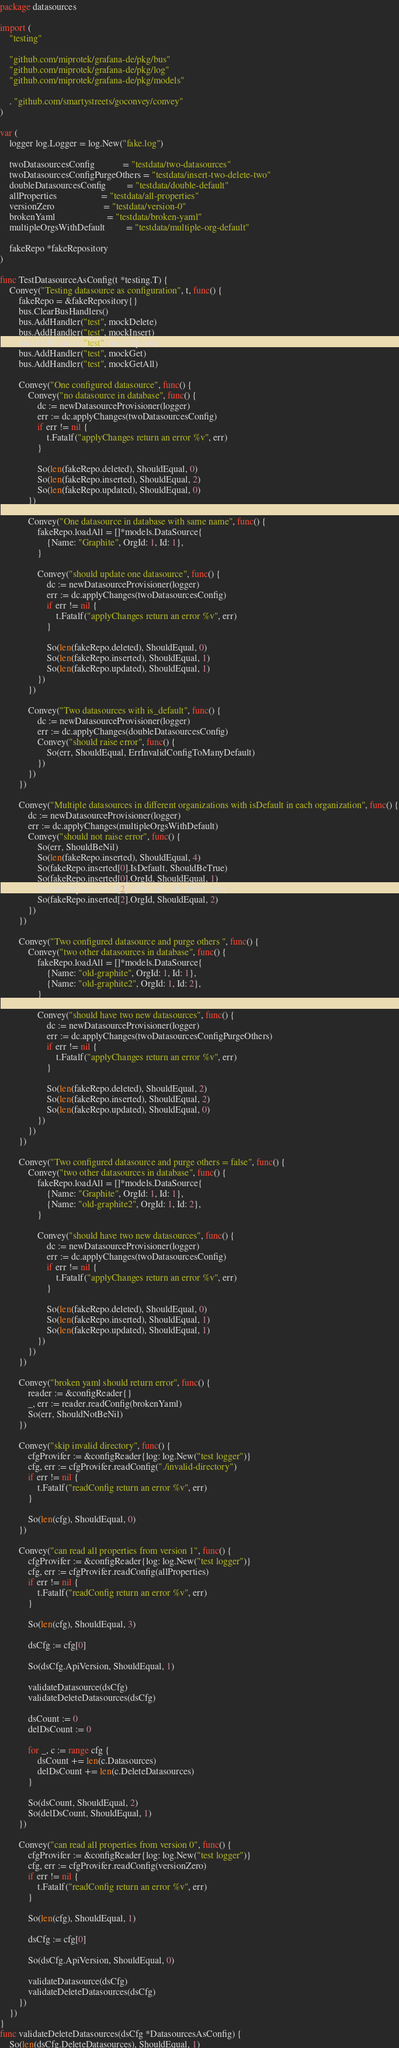<code> <loc_0><loc_0><loc_500><loc_500><_Go_>package datasources

import (
	"testing"

	"github.com/miprotek/grafana-de/pkg/bus"
	"github.com/miprotek/grafana-de/pkg/log"
	"github.com/miprotek/grafana-de/pkg/models"

	. "github.com/smartystreets/goconvey/convey"
)

var (
	logger log.Logger = log.New("fake.log")

	twoDatasourcesConfig            = "testdata/two-datasources"
	twoDatasourcesConfigPurgeOthers = "testdata/insert-two-delete-two"
	doubleDatasourcesConfig         = "testdata/double-default"
	allProperties                   = "testdata/all-properties"
	versionZero                     = "testdata/version-0"
	brokenYaml                      = "testdata/broken-yaml"
	multipleOrgsWithDefault         = "testdata/multiple-org-default"

	fakeRepo *fakeRepository
)

func TestDatasourceAsConfig(t *testing.T) {
	Convey("Testing datasource as configuration", t, func() {
		fakeRepo = &fakeRepository{}
		bus.ClearBusHandlers()
		bus.AddHandler("test", mockDelete)
		bus.AddHandler("test", mockInsert)
		bus.AddHandler("test", mockUpdate)
		bus.AddHandler("test", mockGet)
		bus.AddHandler("test", mockGetAll)

		Convey("One configured datasource", func() {
			Convey("no datasource in database", func() {
				dc := newDatasourceProvisioner(logger)
				err := dc.applyChanges(twoDatasourcesConfig)
				if err != nil {
					t.Fatalf("applyChanges return an error %v", err)
				}

				So(len(fakeRepo.deleted), ShouldEqual, 0)
				So(len(fakeRepo.inserted), ShouldEqual, 2)
				So(len(fakeRepo.updated), ShouldEqual, 0)
			})

			Convey("One datasource in database with same name", func() {
				fakeRepo.loadAll = []*models.DataSource{
					{Name: "Graphite", OrgId: 1, Id: 1},
				}

				Convey("should update one datasource", func() {
					dc := newDatasourceProvisioner(logger)
					err := dc.applyChanges(twoDatasourcesConfig)
					if err != nil {
						t.Fatalf("applyChanges return an error %v", err)
					}

					So(len(fakeRepo.deleted), ShouldEqual, 0)
					So(len(fakeRepo.inserted), ShouldEqual, 1)
					So(len(fakeRepo.updated), ShouldEqual, 1)
				})
			})

			Convey("Two datasources with is_default", func() {
				dc := newDatasourceProvisioner(logger)
				err := dc.applyChanges(doubleDatasourcesConfig)
				Convey("should raise error", func() {
					So(err, ShouldEqual, ErrInvalidConfigToManyDefault)
				})
			})
		})

		Convey("Multiple datasources in different organizations with isDefault in each organization", func() {
			dc := newDatasourceProvisioner(logger)
			err := dc.applyChanges(multipleOrgsWithDefault)
			Convey("should not raise error", func() {
				So(err, ShouldBeNil)
				So(len(fakeRepo.inserted), ShouldEqual, 4)
				So(fakeRepo.inserted[0].IsDefault, ShouldBeTrue)
				So(fakeRepo.inserted[0].OrgId, ShouldEqual, 1)
				So(fakeRepo.inserted[2].IsDefault, ShouldBeTrue)
				So(fakeRepo.inserted[2].OrgId, ShouldEqual, 2)
			})
		})

		Convey("Two configured datasource and purge others ", func() {
			Convey("two other datasources in database", func() {
				fakeRepo.loadAll = []*models.DataSource{
					{Name: "old-graphite", OrgId: 1, Id: 1},
					{Name: "old-graphite2", OrgId: 1, Id: 2},
				}

				Convey("should have two new datasources", func() {
					dc := newDatasourceProvisioner(logger)
					err := dc.applyChanges(twoDatasourcesConfigPurgeOthers)
					if err != nil {
						t.Fatalf("applyChanges return an error %v", err)
					}

					So(len(fakeRepo.deleted), ShouldEqual, 2)
					So(len(fakeRepo.inserted), ShouldEqual, 2)
					So(len(fakeRepo.updated), ShouldEqual, 0)
				})
			})
		})

		Convey("Two configured datasource and purge others = false", func() {
			Convey("two other datasources in database", func() {
				fakeRepo.loadAll = []*models.DataSource{
					{Name: "Graphite", OrgId: 1, Id: 1},
					{Name: "old-graphite2", OrgId: 1, Id: 2},
				}

				Convey("should have two new datasources", func() {
					dc := newDatasourceProvisioner(logger)
					err := dc.applyChanges(twoDatasourcesConfig)
					if err != nil {
						t.Fatalf("applyChanges return an error %v", err)
					}

					So(len(fakeRepo.deleted), ShouldEqual, 0)
					So(len(fakeRepo.inserted), ShouldEqual, 1)
					So(len(fakeRepo.updated), ShouldEqual, 1)
				})
			})
		})

		Convey("broken yaml should return error", func() {
			reader := &configReader{}
			_, err := reader.readConfig(brokenYaml)
			So(err, ShouldNotBeNil)
		})

		Convey("skip invalid directory", func() {
			cfgProvifer := &configReader{log: log.New("test logger")}
			cfg, err := cfgProvifer.readConfig("./invalid-directory")
			if err != nil {
				t.Fatalf("readConfig return an error %v", err)
			}

			So(len(cfg), ShouldEqual, 0)
		})

		Convey("can read all properties from version 1", func() {
			cfgProvifer := &configReader{log: log.New("test logger")}
			cfg, err := cfgProvifer.readConfig(allProperties)
			if err != nil {
				t.Fatalf("readConfig return an error %v", err)
			}

			So(len(cfg), ShouldEqual, 3)

			dsCfg := cfg[0]

			So(dsCfg.ApiVersion, ShouldEqual, 1)

			validateDatasource(dsCfg)
			validateDeleteDatasources(dsCfg)

			dsCount := 0
			delDsCount := 0

			for _, c := range cfg {
				dsCount += len(c.Datasources)
				delDsCount += len(c.DeleteDatasources)
			}

			So(dsCount, ShouldEqual, 2)
			So(delDsCount, ShouldEqual, 1)
		})

		Convey("can read all properties from version 0", func() {
			cfgProvifer := &configReader{log: log.New("test logger")}
			cfg, err := cfgProvifer.readConfig(versionZero)
			if err != nil {
				t.Fatalf("readConfig return an error %v", err)
			}

			So(len(cfg), ShouldEqual, 1)

			dsCfg := cfg[0]

			So(dsCfg.ApiVersion, ShouldEqual, 0)

			validateDatasource(dsCfg)
			validateDeleteDatasources(dsCfg)
		})
	})
}
func validateDeleteDatasources(dsCfg *DatasourcesAsConfig) {
	So(len(dsCfg.DeleteDatasources), ShouldEqual, 1)</code> 